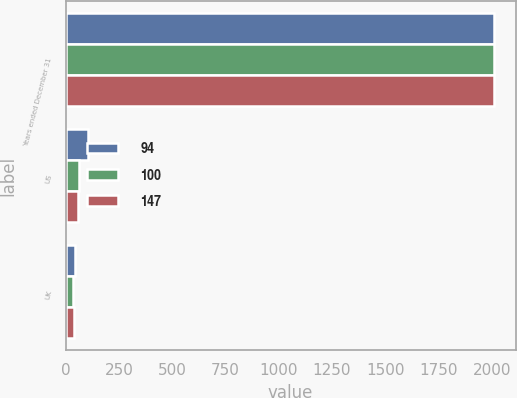Convert chart to OTSL. <chart><loc_0><loc_0><loc_500><loc_500><stacked_bar_chart><ecel><fcel>Years ended December 31<fcel>US<fcel>UK<nl><fcel>94<fcel>2011<fcel>104<fcel>43<nl><fcel>100<fcel>2010<fcel>65<fcel>35<nl><fcel>147<fcel>2009<fcel>56<fcel>38<nl></chart> 